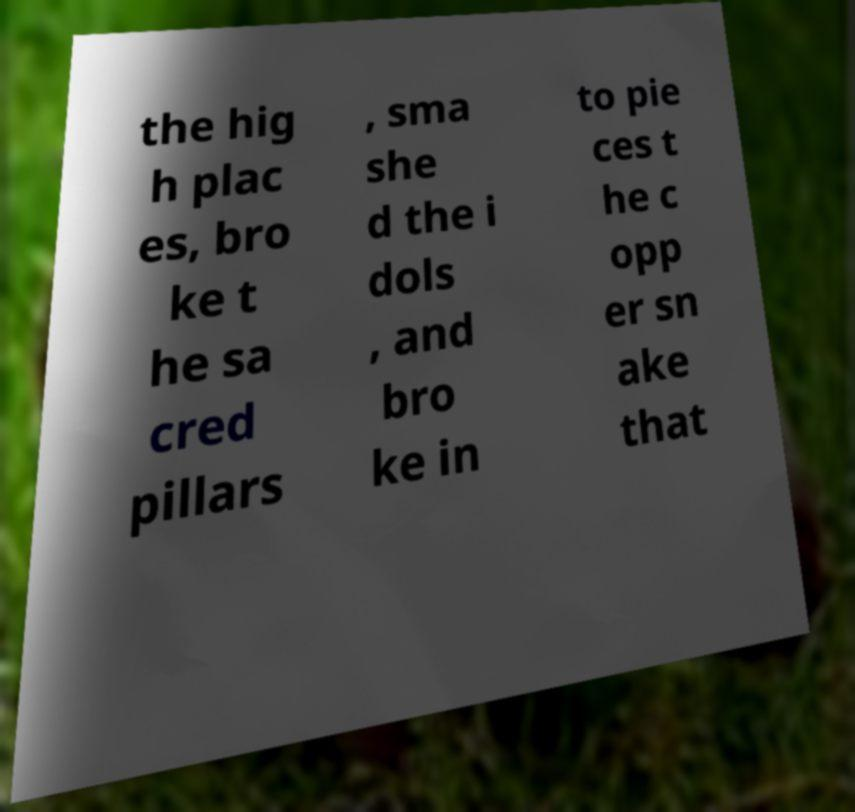Please identify and transcribe the text found in this image. the hig h plac es, bro ke t he sa cred pillars , sma she d the i dols , and bro ke in to pie ces t he c opp er sn ake that 